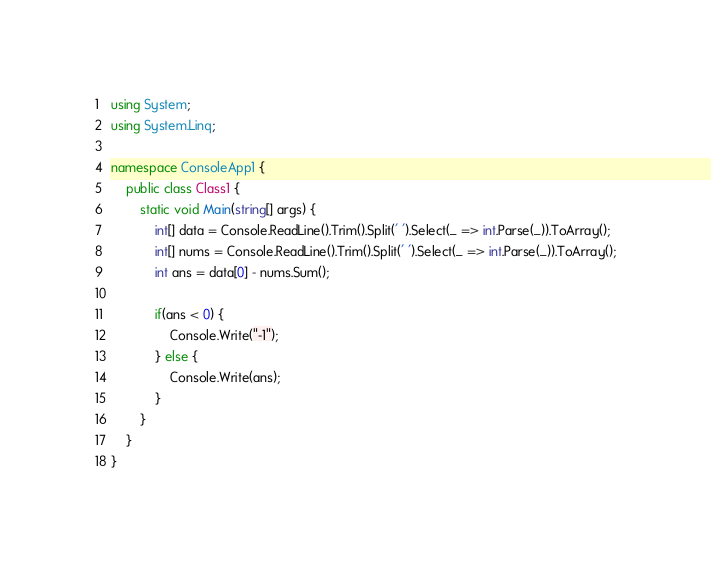<code> <loc_0><loc_0><loc_500><loc_500><_C#_>using System;
using System.Linq;

namespace ConsoleApp1 {
    public class Class1 {
        static void Main(string[] args) {
            int[] data = Console.ReadLine().Trim().Split(' ').Select(_ => int.Parse(_)).ToArray();
            int[] nums = Console.ReadLine().Trim().Split(' ').Select(_ => int.Parse(_)).ToArray();
            int ans = data[0] - nums.Sum();
            
            if(ans < 0) {
                Console.Write("-1");
            } else {
                Console.Write(ans);
            }
        }
    }
}</code> 